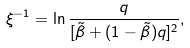Convert formula to latex. <formula><loc_0><loc_0><loc_500><loc_500>\xi ^ { - 1 } = \ln \frac { q } { [ \tilde { \beta } + ( 1 - \tilde { \beta } ) q ] ^ { 2 } } ,</formula> 